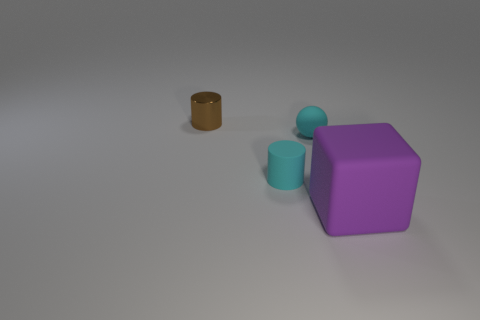Is there any other thing that has the same size as the purple rubber cube?
Offer a terse response. No. There is a cyan matte thing that is to the right of the cyan rubber cylinder; is it the same size as the big purple object?
Keep it short and to the point. No. How many brown metallic cylinders are in front of the small object that is right of the tiny cyan rubber object that is left of the ball?
Your answer should be compact. 0. What size is the object that is both left of the matte ball and in front of the metal cylinder?
Provide a succinct answer. Small. What number of other things are there of the same shape as the big purple object?
Provide a short and direct response. 0. There is a purple matte object; how many big rubber blocks are in front of it?
Give a very brief answer. 0. Is the number of small metallic cylinders that are in front of the big object less than the number of brown objects that are behind the cyan matte cylinder?
Ensure brevity in your answer.  Yes. The tiny matte thing left of the cyan thing that is behind the tiny cylinder that is in front of the brown shiny cylinder is what shape?
Offer a very short reply. Cylinder. What is the shape of the rubber object that is to the left of the big purple block and in front of the matte ball?
Ensure brevity in your answer.  Cylinder. Is there a object that has the same material as the big block?
Ensure brevity in your answer.  Yes. 